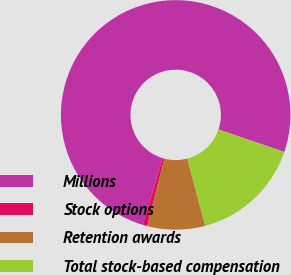Convert chart. <chart><loc_0><loc_0><loc_500><loc_500><pie_chart><fcel>Millions<fcel>Stock options<fcel>Retention awards<fcel>Total stock-based compensation<nl><fcel>75.6%<fcel>0.64%<fcel>8.13%<fcel>15.63%<nl></chart> 